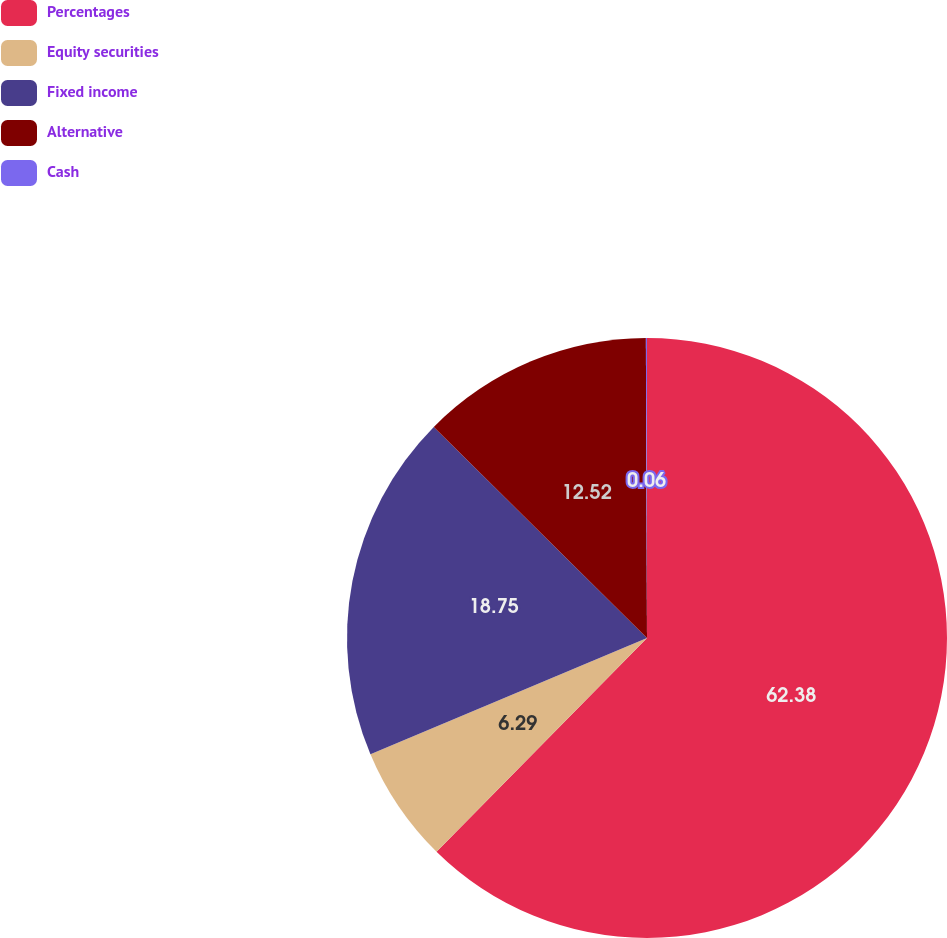Convert chart to OTSL. <chart><loc_0><loc_0><loc_500><loc_500><pie_chart><fcel>Percentages<fcel>Equity securities<fcel>Fixed income<fcel>Alternative<fcel>Cash<nl><fcel>62.37%<fcel>6.29%<fcel>18.75%<fcel>12.52%<fcel>0.06%<nl></chart> 